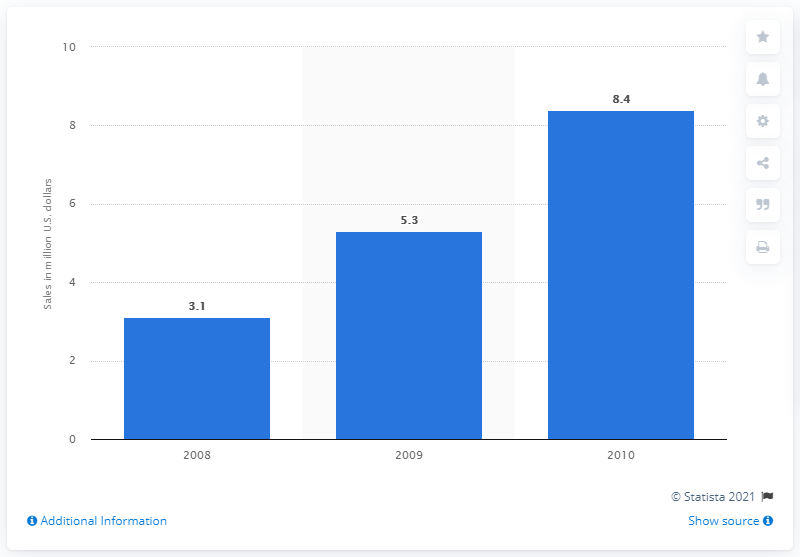Give some essential details in this illustration. In 2010, the United States generated approximately 8.4 billion dollars in revenue from the sale of compression garments. 